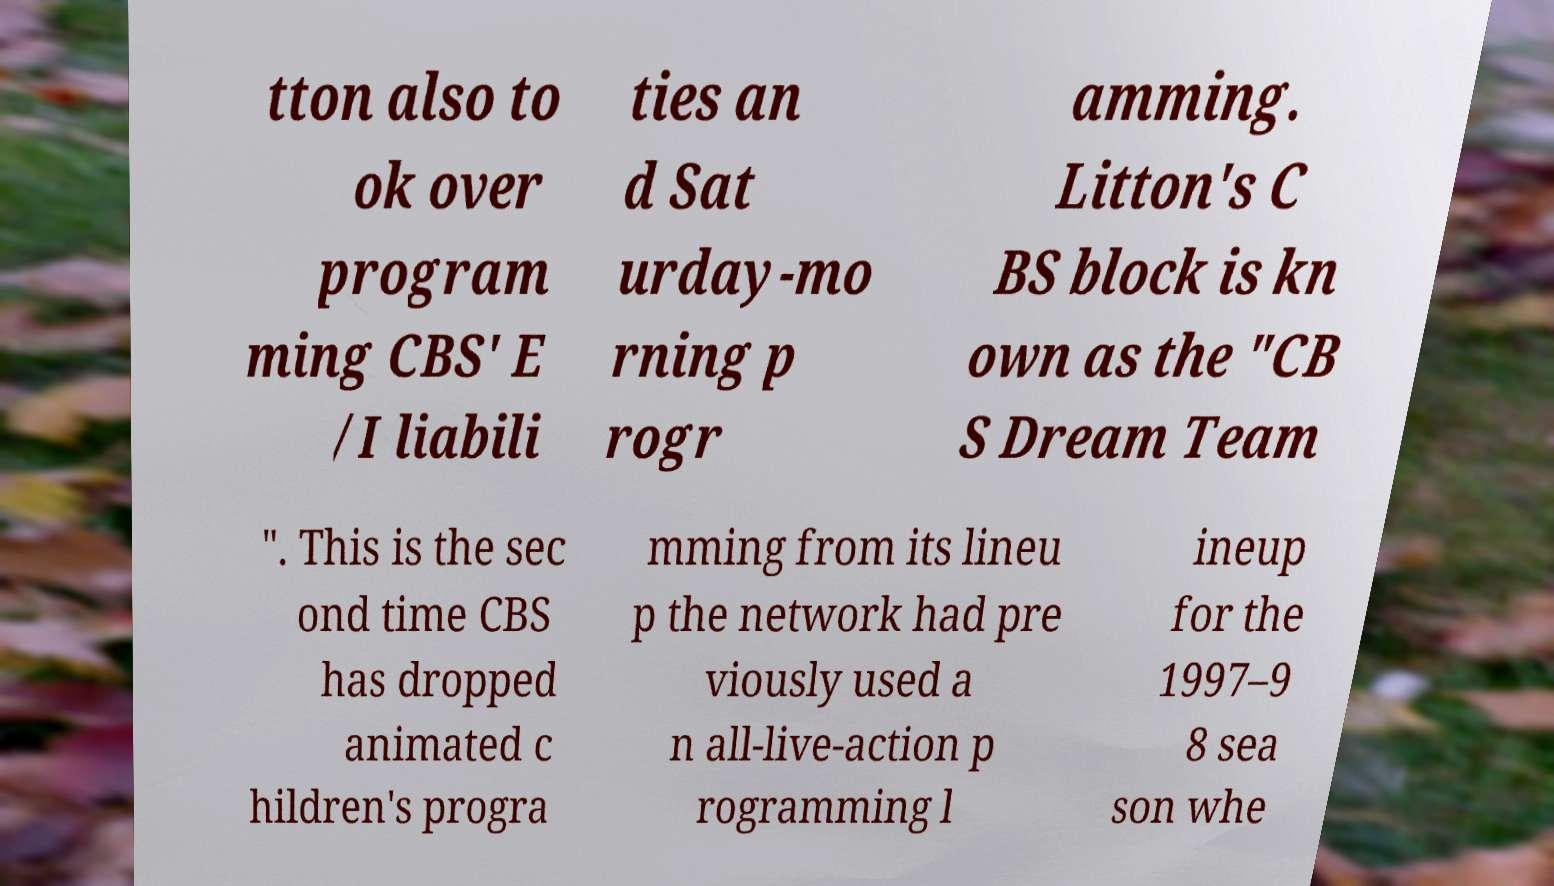Could you assist in decoding the text presented in this image and type it out clearly? tton also to ok over program ming CBS' E /I liabili ties an d Sat urday-mo rning p rogr amming. Litton's C BS block is kn own as the "CB S Dream Team ". This is the sec ond time CBS has dropped animated c hildren's progra mming from its lineu p the network had pre viously used a n all-live-action p rogramming l ineup for the 1997–9 8 sea son whe 